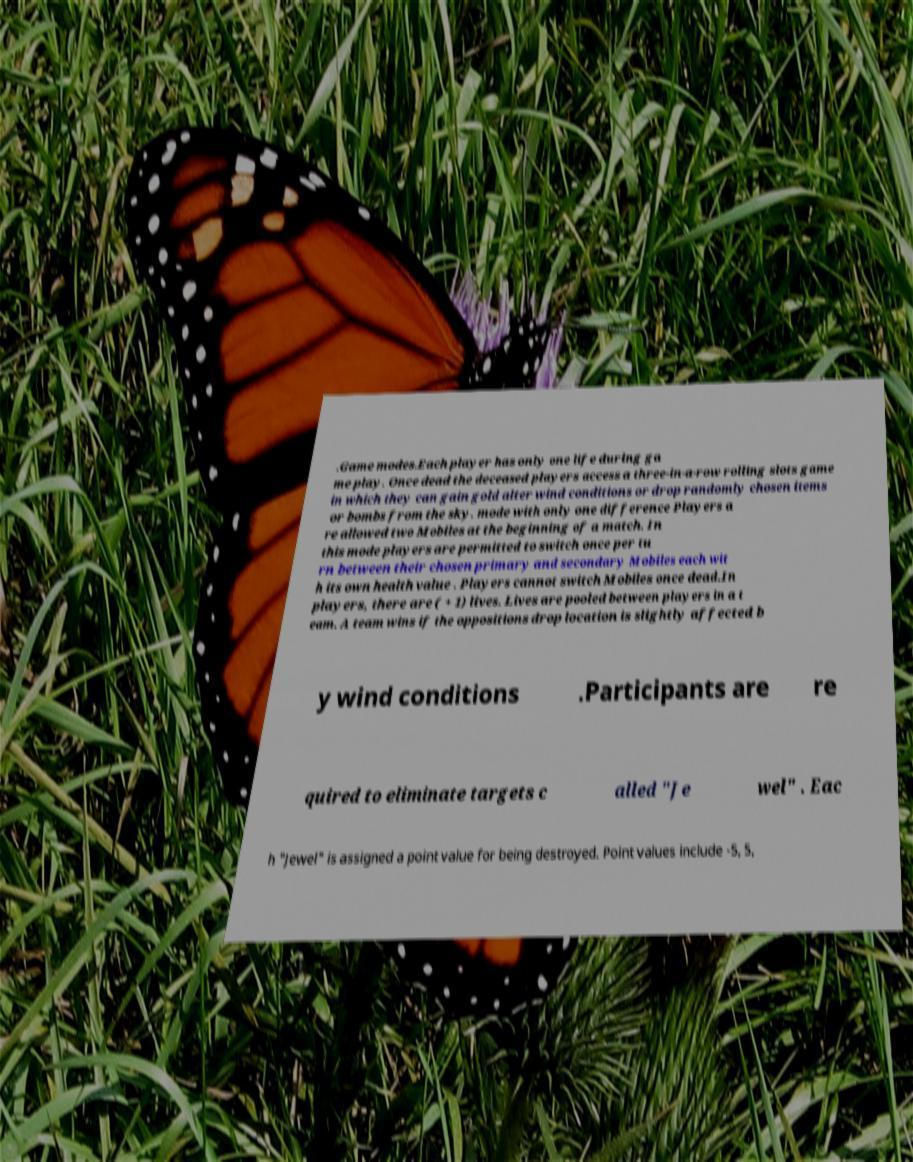Could you assist in decoding the text presented in this image and type it out clearly? .Game modes.Each player has only one life during ga me play. Once dead the deceased players access a three-in-a-row rolling slots game in which they can gain gold alter wind conditions or drop randomly chosen items or bombs from the sky. mode with only one difference Players a re allowed two Mobiles at the beginning of a match. In this mode players are permitted to switch once per tu rn between their chosen primary and secondary Mobiles each wit h its own health value . Players cannot switch Mobiles once dead.In players, there are ( + 1) lives. Lives are pooled between players in a t eam. A team wins if the oppositions drop location is slightly affected b y wind conditions .Participants are re quired to eliminate targets c alled "Je wel" . Eac h "Jewel" is assigned a point value for being destroyed. Point values include -5, 5, 